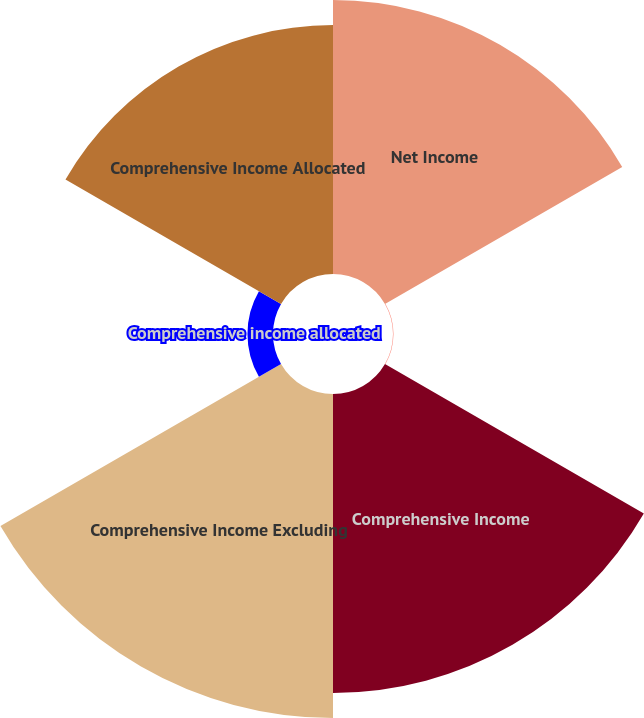Convert chart. <chart><loc_0><loc_0><loc_500><loc_500><pie_chart><fcel>Net Income<fcel>Post retirement benefit<fcel>Comprehensive Income<fcel>Comprehensive Income Excluding<fcel>Comprehensive income allocated<fcel>Comprehensive Income Allocated<nl><fcel>23.38%<fcel>0.04%<fcel>25.51%<fcel>27.65%<fcel>2.18%<fcel>21.24%<nl></chart> 